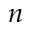<formula> <loc_0><loc_0><loc_500><loc_500>n</formula> 